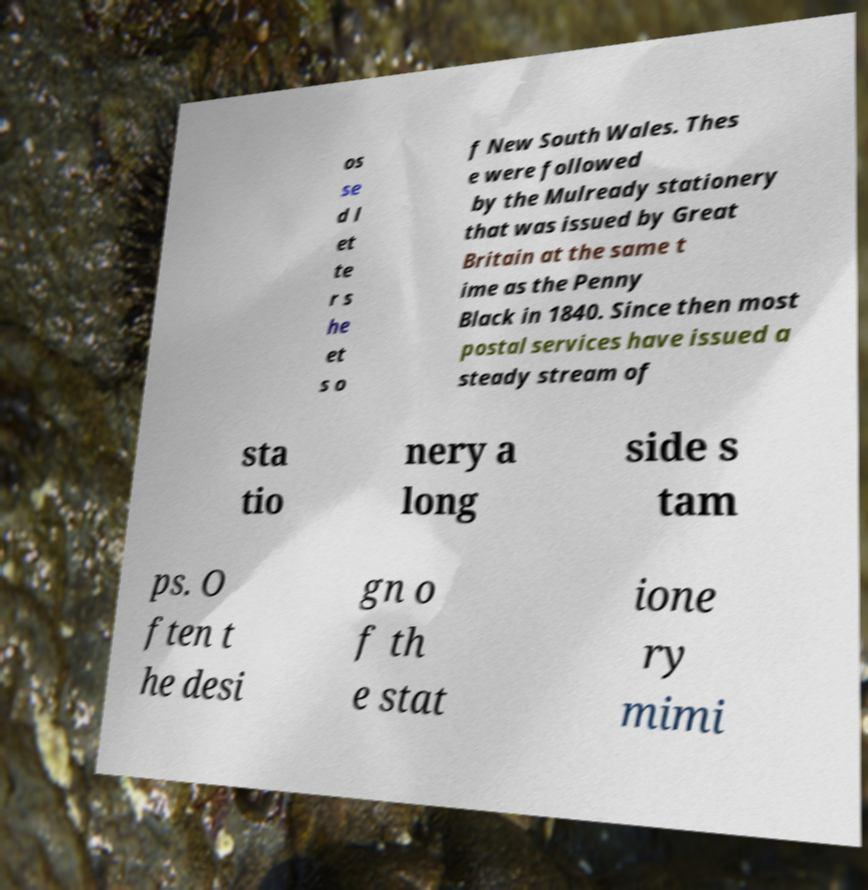Can you read and provide the text displayed in the image?This photo seems to have some interesting text. Can you extract and type it out for me? os se d l et te r s he et s o f New South Wales. Thes e were followed by the Mulready stationery that was issued by Great Britain at the same t ime as the Penny Black in 1840. Since then most postal services have issued a steady stream of sta tio nery a long side s tam ps. O ften t he desi gn o f th e stat ione ry mimi 